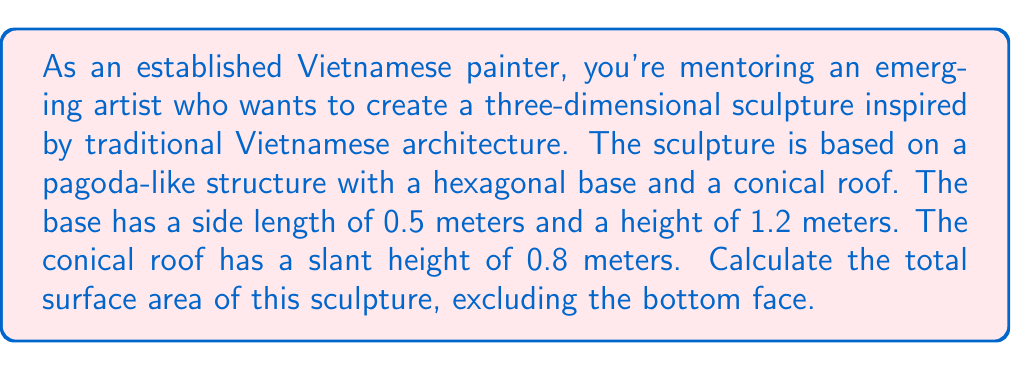What is the answer to this math problem? Let's break this problem down into steps:

1. Calculate the surface area of the hexagonal base (lateral faces only):
   - Area of one rectangular face = side length × height
   - $A_{rect} = 0.5 \text{ m} \times 1.2 \text{ m} = 0.6 \text{ m}^2$
   - There are 6 identical faces, so total area = $6 \times 0.6 = 3.6 \text{ m}^2$

2. Calculate the surface area of the conical roof:
   - We need to find the radius of the base of the cone first
   - The hexagon's circumradius $R$ is given by: $R = \frac{s}{\sqrt{3}}$, where $s$ is the side length
   - $R = \frac{0.5}{\sqrt{3}} \approx 0.2887 \text{ m}$
   - Area of the conical surface: $A_{cone} = \pi R s$, where $s$ is the slant height
   - $A_{cone} = \pi \times 0.2887 \times 0.8 \approx 0.7253 \text{ m}^2$

3. Sum up the total surface area:
   - Total surface area = Area of hexagonal faces + Area of conical roof
   - $A_{total} = 3.6 \text{ m}^2 + 0.7253 \text{ m}^2 = 4.3253 \text{ m}^2$

[asy]
import geometry;

size(200);

// Hexagonal base
pair[] hexagon = {dir(0), dir(60), dir(120), dir(180), dir(240), dir(300)};
for (int i = 0; i < 6; ++i) {
  draw(scale(0.5)*hexagon[i]--scale(0.5)*hexagon[(i+1)%6]);
}

// Vertical lines
for (int i = 0; i < 6; ++i) {
  draw(scale(0.5)*hexagon[i]--(scale(0.5)*hexagon[i]+1.2*Z));
}

// Conical roof
draw(circle(Z*1.2, 0.2887));
for (int i = 0; i < 6; ++i) {
  draw((scale(0.5)*hexagon[i]+1.2*Z)--(0,0,2));
}

label("0.5 m", (0.25,0), S);
label("1.2 m", (0.5,0.6), E);
label("0.8 m", (0.3,0.3,1.6), NE);

[/asy]
Answer: The total surface area of the sculpture is approximately $4.3253 \text{ m}^2$. 